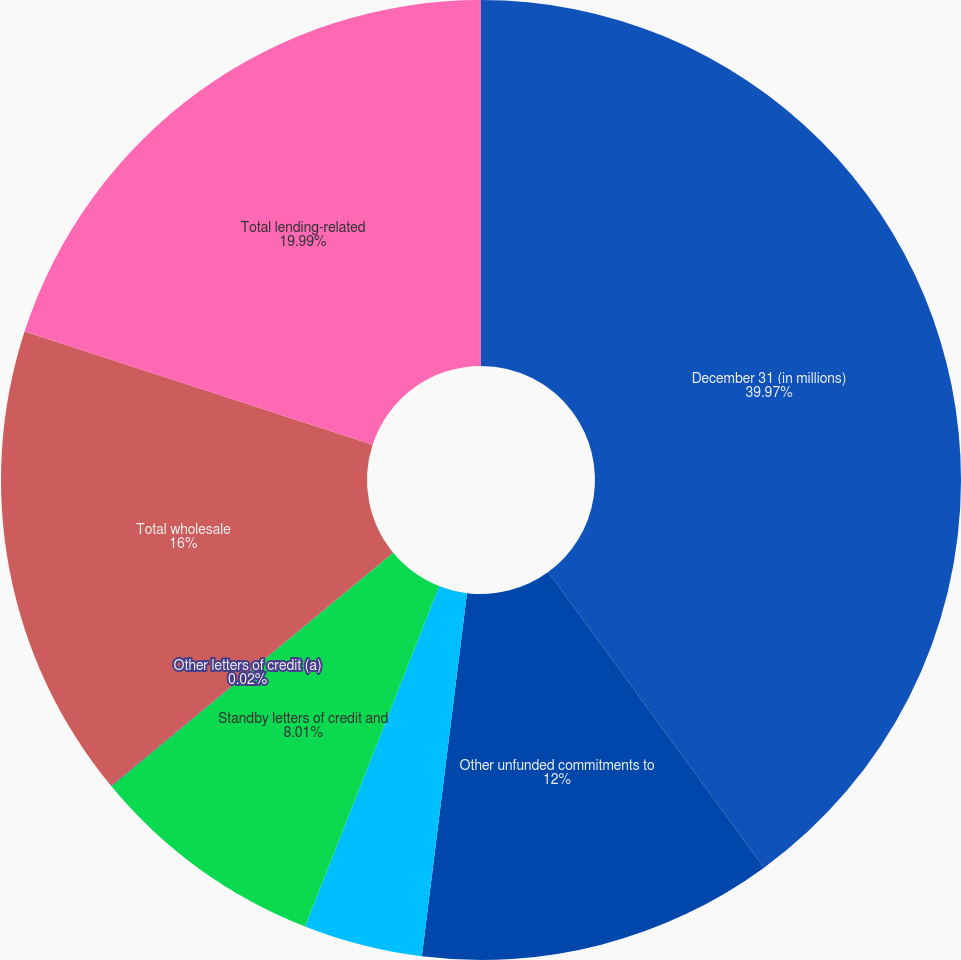Convert chart. <chart><loc_0><loc_0><loc_500><loc_500><pie_chart><fcel>December 31 (in millions)<fcel>Other unfunded commitments to<fcel>Asset purchase agreements (d)<fcel>Standby letters of credit and<fcel>Other letters of credit (a)<fcel>Total wholesale<fcel>Total lending-related<nl><fcel>39.96%<fcel>12.0%<fcel>4.01%<fcel>8.01%<fcel>0.02%<fcel>16.0%<fcel>19.99%<nl></chart> 